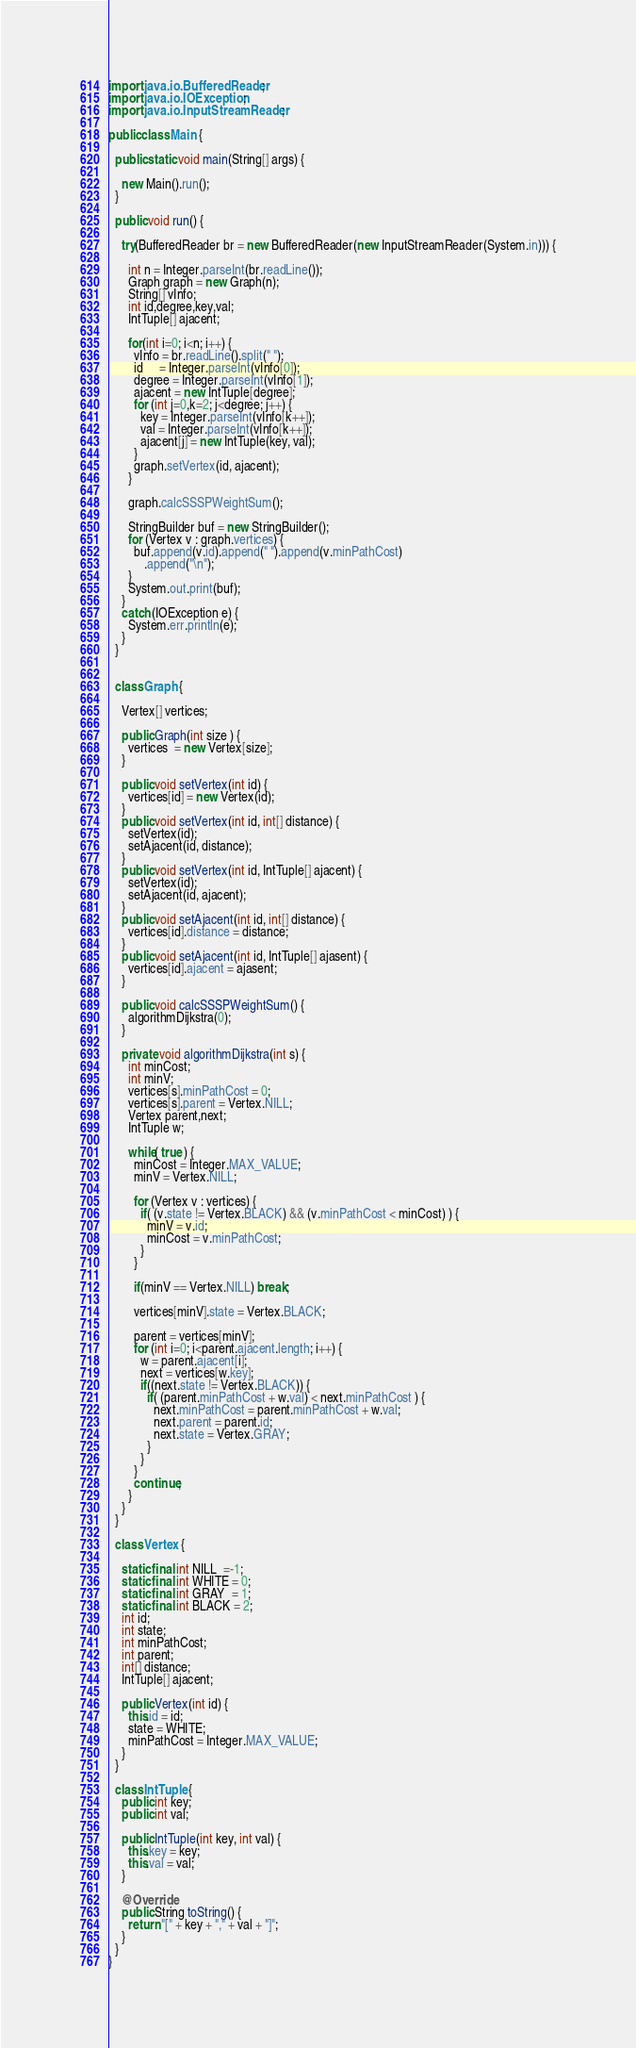Convert code to text. <code><loc_0><loc_0><loc_500><loc_500><_Java_>import java.io.BufferedReader;
import java.io.IOException;
import java.io.InputStreamReader;

public class Main {

  public static void main(String[] args) {
    
    new Main().run();
  }

  public void run() {

    try(BufferedReader br = new BufferedReader(new InputStreamReader(System.in))) {

      int n = Integer.parseInt(br.readLine());
      Graph graph = new Graph(n);
      String[] vInfo;
      int id,degree,key,val;
      IntTuple[] ajacent;

      for(int i=0; i<n; i++) {
        vInfo = br.readLine().split(" ");
        id     = Integer.parseInt(vInfo[0]);
        degree = Integer.parseInt(vInfo[1]);
        ajacent = new IntTuple[degree];
        for (int j=0,k=2; j<degree; j++) {
          key = Integer.parseInt(vInfo[k++]);
          val = Integer.parseInt(vInfo[k++]);
          ajacent[j] = new IntTuple(key, val);
        }
        graph.setVertex(id, ajacent);
      }

      graph.calcSSSPWeightSum();

      StringBuilder buf = new StringBuilder();
      for (Vertex v : graph.vertices) {
        buf.append(v.id).append(" ").append(v.minPathCost)
           .append("\n");
      }
      System.out.print(buf);
    }
    catch (IOException e) {
      System.err.println(e);
    }
  }


  class Graph {

    Vertex[] vertices;

    public Graph(int size ) {
      vertices  = new Vertex[size];
    }

    public void setVertex(int id) {
      vertices[id] = new Vertex(id);
    }
    public void setVertex(int id, int[] distance) {
      setVertex(id);
      setAjacent(id, distance);
    }
    public void setVertex(int id, IntTuple[] ajacent) {
      setVertex(id);
      setAjacent(id, ajacent);
    }
    public void setAjacent(int id, int[] distance) {
      vertices[id].distance = distance;
    }
    public void setAjacent(int id, IntTuple[] ajasent) {
      vertices[id].ajacent = ajasent;
    }

    public void calcSSSPWeightSum() {
      algorithmDijkstra(0);
    }

    private void algorithmDijkstra(int s) {
      int minCost;
      int minV;
      vertices[s].minPathCost = 0;
      vertices[s].parent = Vertex.NILL;
      Vertex parent,next;
      IntTuple w;

      while( true ) {
        minCost = Integer.MAX_VALUE;
        minV = Vertex.NILL;

        for (Vertex v : vertices) {
          if( (v.state != Vertex.BLACK) && (v.minPathCost < minCost) ) {
            minV = v.id;
            minCost = v.minPathCost;
          }
        }

        if(minV == Vertex.NILL) break;

        vertices[minV].state = Vertex.BLACK;

        parent = vertices[minV];
        for (int i=0; i<parent.ajacent.length; i++) {
          w = parent.ajacent[i];
          next = vertices[w.key];
          if((next.state != Vertex.BLACK)) {
            if( (parent.minPathCost + w.val) < next.minPathCost ) {
              next.minPathCost = parent.minPathCost + w.val;
              next.parent = parent.id;
              next.state = Vertex.GRAY;
            }
          }
        }
        continue;
      }
    }
  }

  class Vertex {

    static final int NILL  =-1;
    static final int WHITE = 0;
    static final int GRAY  = 1;
    static final int BLACK = 2;
    int id;
    int state;
    int minPathCost;
    int parent;
    int[] distance;
    IntTuple[] ajacent;

    public Vertex(int id) {
      this.id = id;
      state = WHITE;
      minPathCost = Integer.MAX_VALUE;
    }
  }

  class IntTuple {
    public int key;
    public int val;

    public IntTuple(int key, int val) {
      this.key = key;
      this.val = val;
    }

    @Override
    public String toString() {
      return "[" + key + "," + val + "]";
    }
  }
}
</code> 